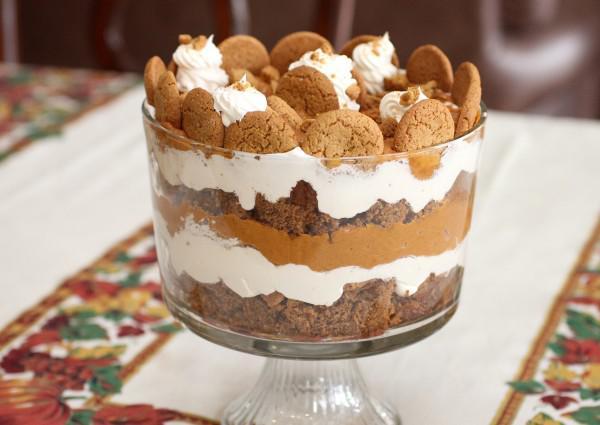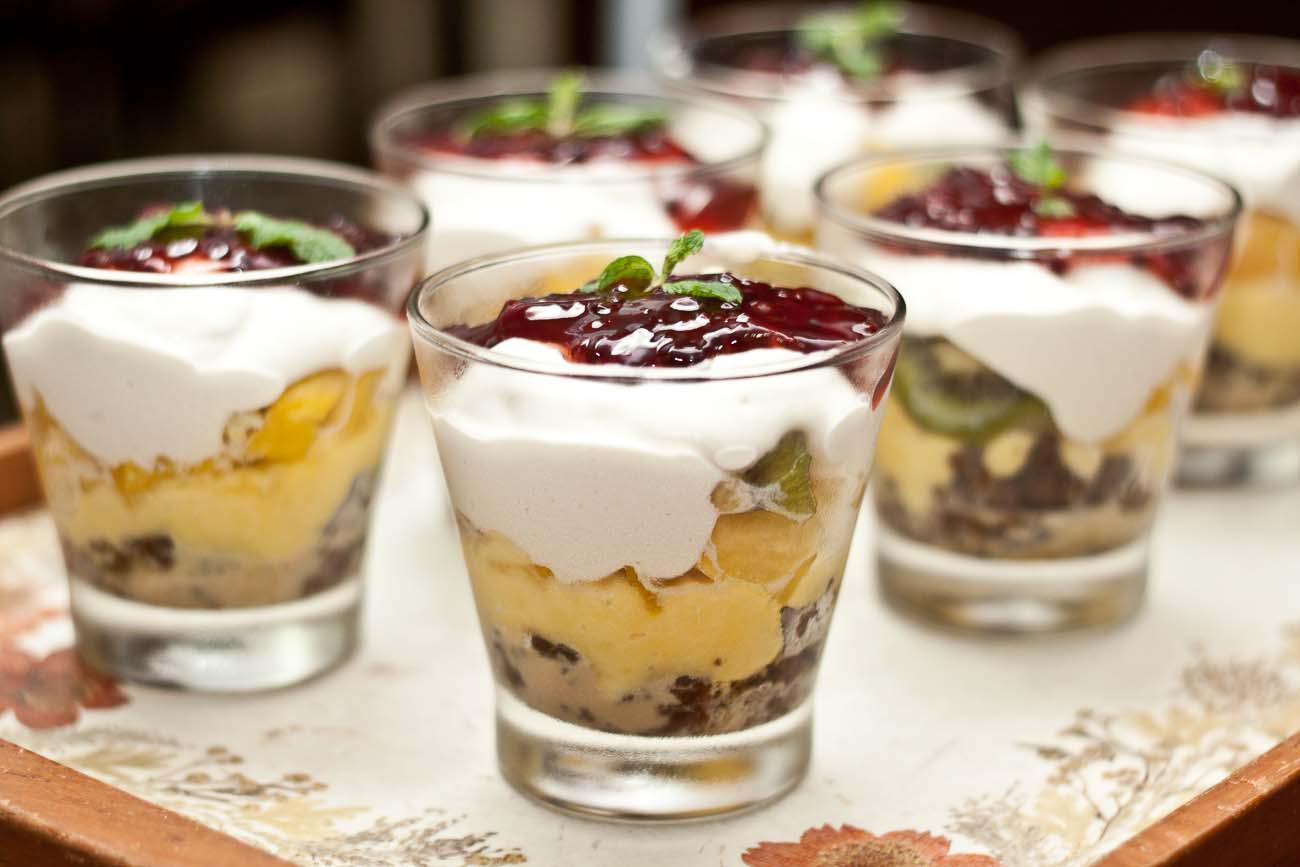The first image is the image on the left, the second image is the image on the right. Analyze the images presented: Is the assertion "In at least one image, an untouched dessert is served in a large bowl, rather than individual serving dishes." valid? Answer yes or no. Yes. 